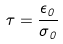Convert formula to latex. <formula><loc_0><loc_0><loc_500><loc_500>\tau = \frac { \epsilon _ { 0 } } { \sigma _ { 0 } }</formula> 